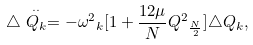Convert formula to latex. <formula><loc_0><loc_0><loc_500><loc_500>\triangle \stackrel { \cdot \cdot } { Q _ { k } } = - { \omega ^ { 2 } } _ { k } [ 1 + \frac { 1 2 \mu } { N } { Q ^ { 2 } } _ { \frac { N } { 2 } } ] \triangle Q _ { k } ,</formula> 